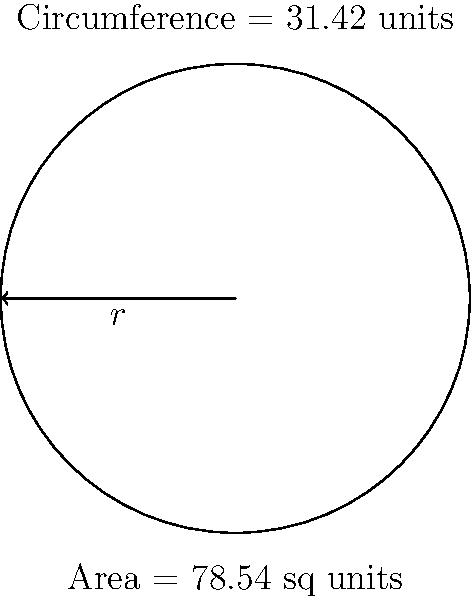As a strategic planning manager, you're tasked with optimizing the layout of a circular operations area. Given that the area of this circular space is 78.54 square units and its circumference is 31.42 units, calculate the radius of the circle. Round your answer to two decimal places. Let's approach this step-by-step:

1) We know two formulas for a circle:
   Area: $A = \pi r^2$
   Circumference: $C = 2\pi r$

2) We're given:
   Area $(A) = 78.54$ sq units
   Circumference $(C) = 31.42$ units

3) Let's use the circumference formula first:
   $31.42 = 2\pi r$

4) Solve for $r$:
   $r = \frac{31.42}{2\pi} = 5$ units

5) To verify, let's use this in the area formula:
   $A = \pi r^2 = \pi (5)^2 = 78.54$ sq units

6) This matches our given area, confirming our calculation.

7) Rounding to two decimal places:
   $r \approx 5.00$ units

This radius is crucial for optimizing the layout of your circular operations area, allowing for efficient space utilization and strategic placement of resources.
Answer: $5.00$ units 